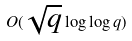Convert formula to latex. <formula><loc_0><loc_0><loc_500><loc_500>O ( \sqrt { q } \log \log q )</formula> 